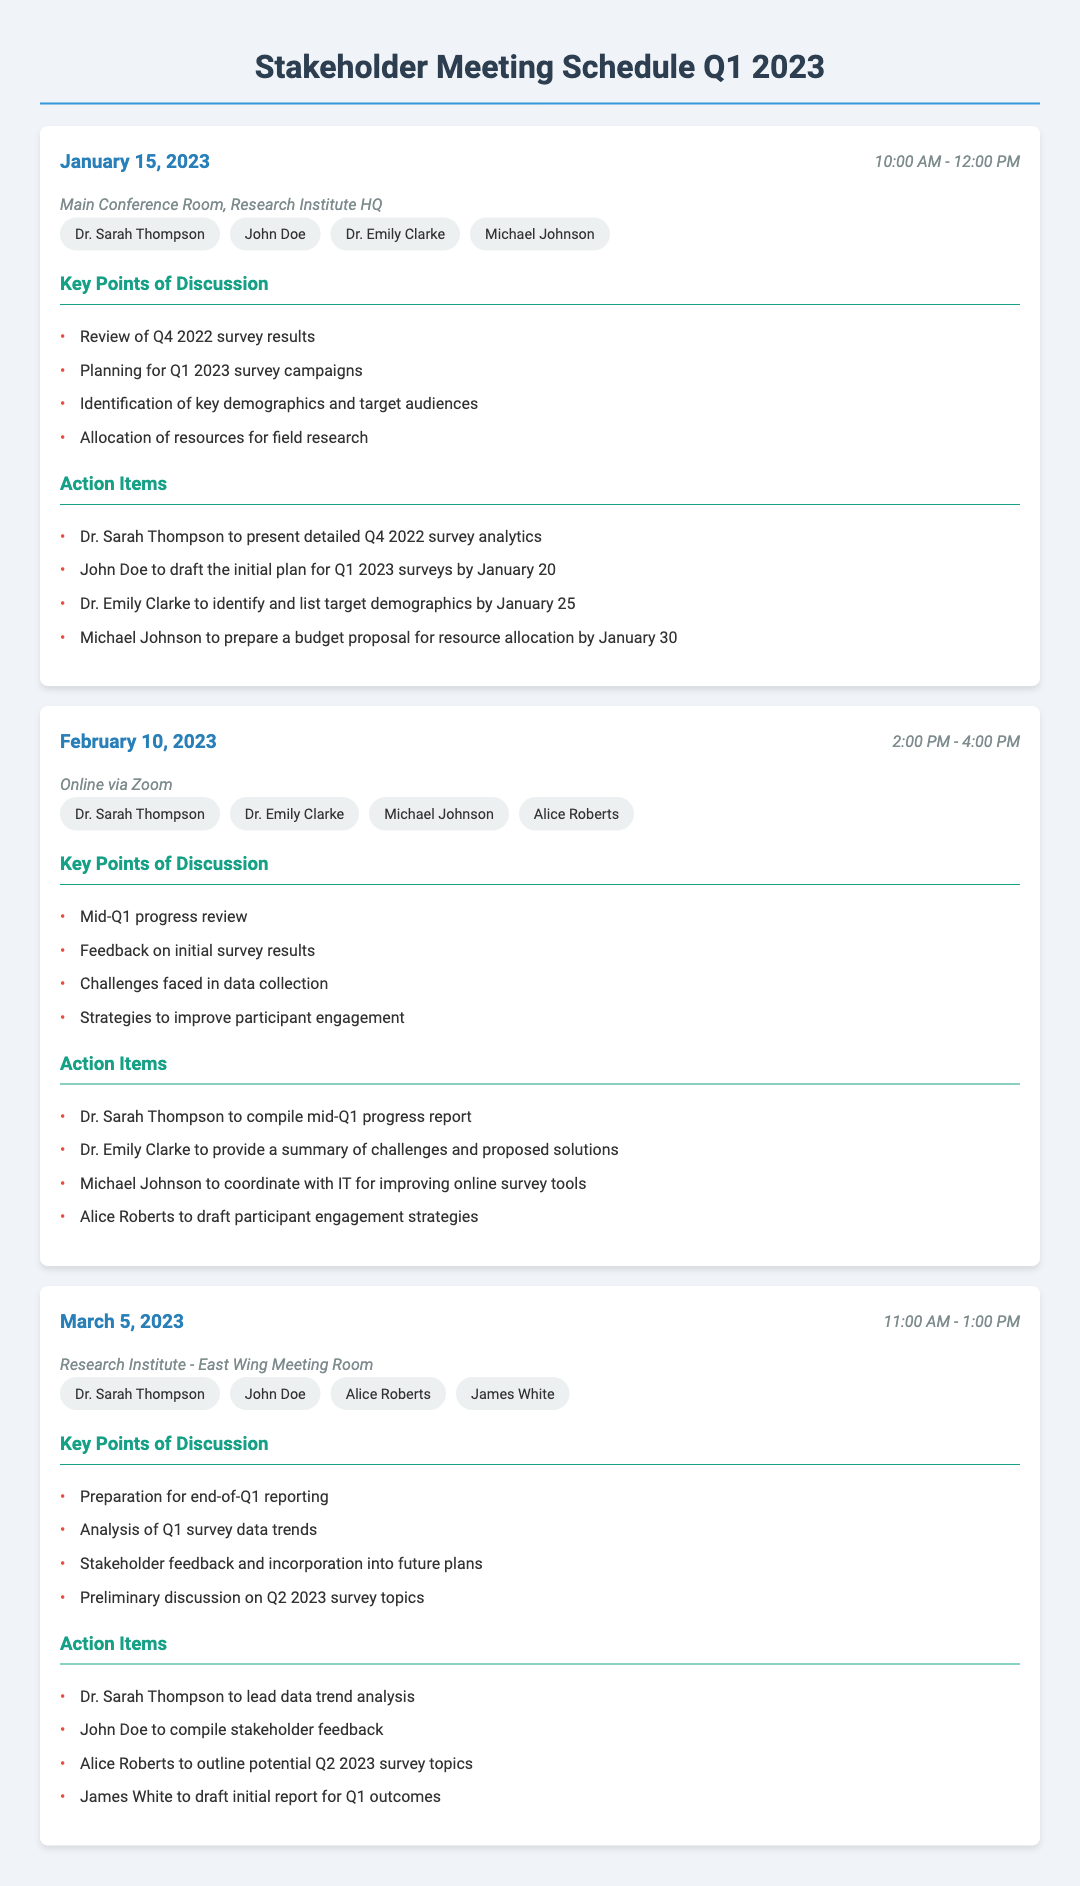What is the date of the first meeting? The date of the first meeting is mentioned as January 15, 2023.
Answer: January 15, 2023 Who is responsible for presenting Q4 2022 survey analytics? The document states that Dr. Sarah Thompson will present detailed Q4 2022 survey analytics.
Answer: Dr. Sarah Thompson What time does the February meeting start? The start time of the February meeting is noted as 2:00 PM.
Answer: 2:00 PM How many participants were listed for the March meeting? The document lists four participants for the March meeting.
Answer: Four What was one of the key points of discussion for the February meeting? One of the key discussion points was the mid-Q1 progress review.
Answer: Mid-Q1 progress review Which room was used for the first meeting? The location for the first meeting is the Main Conference Room, Research Institute HQ.
Answer: Main Conference Room, Research Institute HQ What action item is assigned to John Doe for the first meeting? John Doe is tasked with drafting the initial plan for Q1 2023 surveys by January 20.
Answer: Draft the initial plan for Q1 2023 surveys by January 20 What was discussed regarding data collection challenges in February? The discussion included feedback on initial survey results and challenges faced in data collection.
Answer: Feedback on initial survey results and challenges faced in data collection What is the primary purpose of the stakeholder meetings detailed in the document? The meetings are primarily focused on reviews, planning, and discussion of survey campaigns and results.
Answer: Reviews, planning, and discussion of survey campaigns and results 